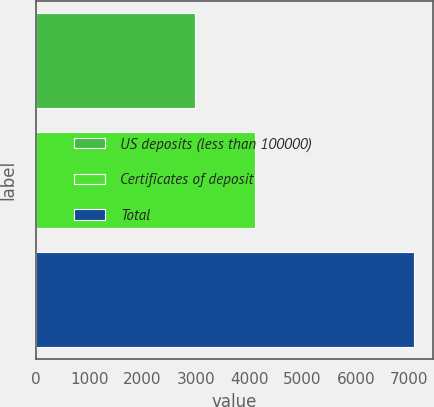<chart> <loc_0><loc_0><loc_500><loc_500><bar_chart><fcel>US deposits (less than 100000)<fcel>Certificates of deposit<fcel>Total<nl><fcel>2976<fcel>4112<fcel>7088<nl></chart> 